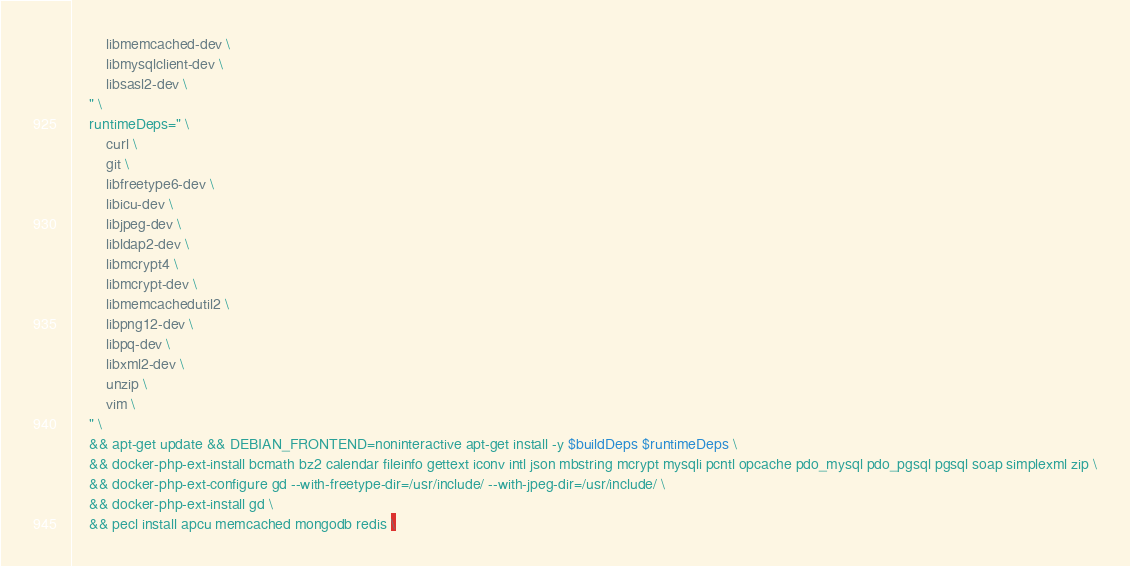Convert code to text. <code><loc_0><loc_0><loc_500><loc_500><_Dockerfile_>        libmemcached-dev \
        libmysqlclient-dev \
        libsasl2-dev \
    " \
    runtimeDeps=" \
        curl \
        git \
        libfreetype6-dev \
        libicu-dev \
        libjpeg-dev \
        libldap2-dev \
        libmcrypt4 \
        libmcrypt-dev \
        libmemcachedutil2 \
        libpng12-dev \
        libpq-dev \
        libxml2-dev \
        unzip \
        vim \
    " \
    && apt-get update && DEBIAN_FRONTEND=noninteractive apt-get install -y $buildDeps $runtimeDeps \
    && docker-php-ext-install bcmath bz2 calendar fileinfo gettext iconv intl json mbstring mcrypt mysqli pcntl opcache pdo_mysql pdo_pgsql pgsql soap simplexml zip \
    && docker-php-ext-configure gd --with-freetype-dir=/usr/include/ --with-jpeg-dir=/usr/include/ \
    && docker-php-ext-install gd \
    && pecl install apcu memcached mongodb redis \</code> 